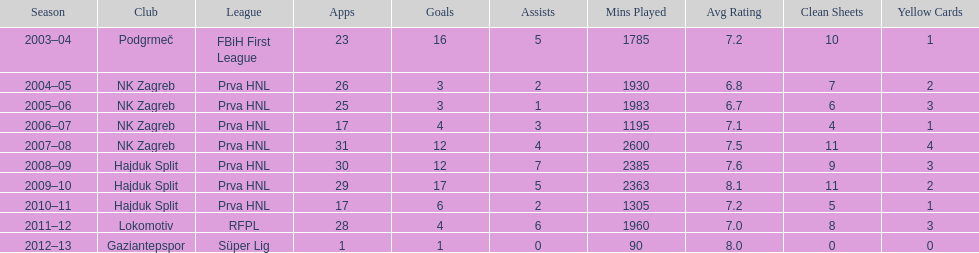After scoring against bulgaria in zenica, ibricic also scored against this team in a 7-0 victory in zenica less then a month after the friendly match against bulgaria. Estonia. 